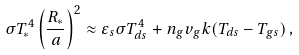<formula> <loc_0><loc_0><loc_500><loc_500>\sigma T _ { * } ^ { 4 } \left ( \frac { R _ { * } } { a } \right ) ^ { 2 } \approx \varepsilon _ { s } \sigma T _ { d s } ^ { 4 } + n _ { g } v _ { g } k ( T _ { d s } - T _ { g s } ) \, ,</formula> 